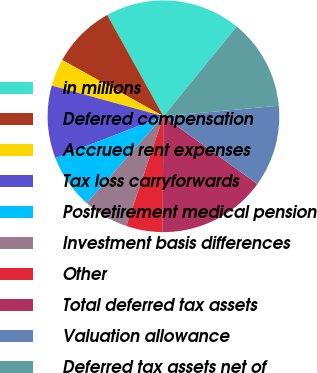Convert chart. <chart><loc_0><loc_0><loc_500><loc_500><pie_chart><fcel>in millions<fcel>Deferred compensation<fcel>Accrued rent expenses<fcel>Tax loss carryforwards<fcel>Postretirement medical pension<fcel>Investment basis differences<fcel>Other<fcel>Total deferred tax assets<fcel>Valuation allowance<fcel>Deferred tax assets net of<nl><fcel>18.97%<fcel>8.86%<fcel>3.81%<fcel>10.13%<fcel>7.6%<fcel>6.34%<fcel>5.07%<fcel>15.18%<fcel>11.39%<fcel>12.65%<nl></chart> 